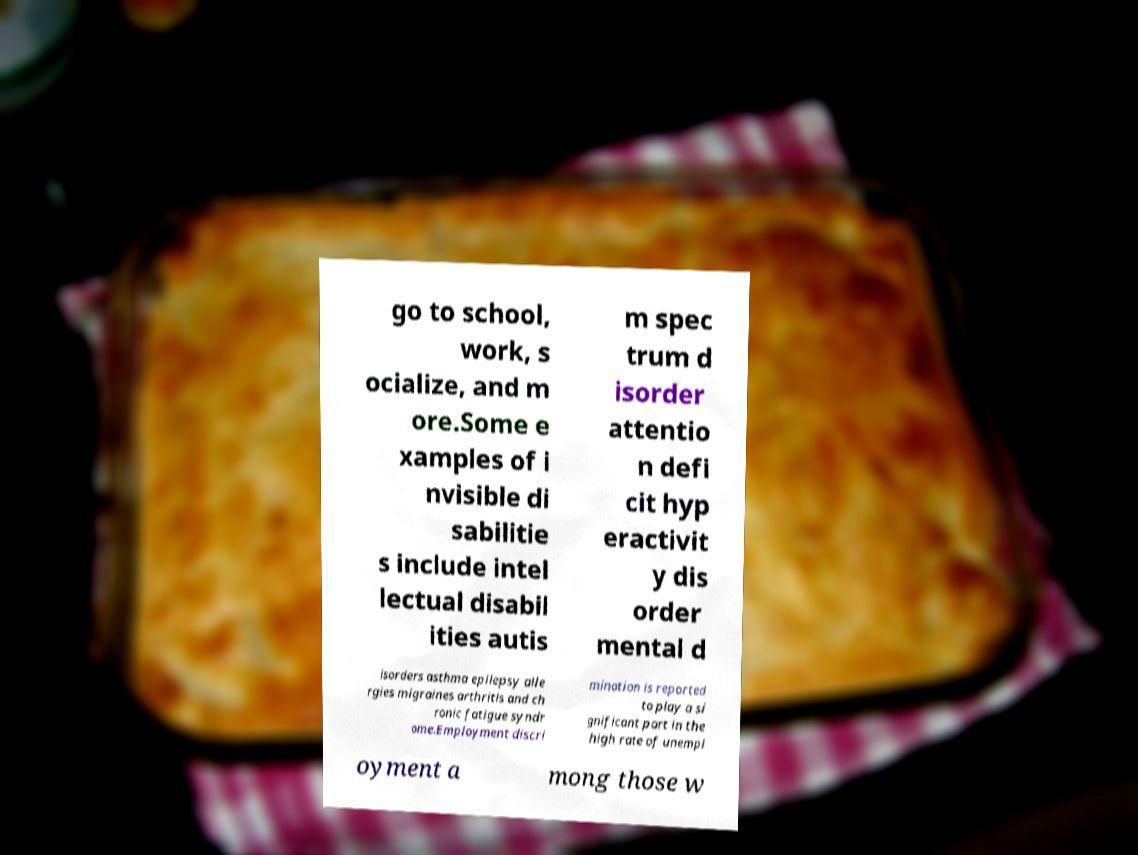What messages or text are displayed in this image? I need them in a readable, typed format. go to school, work, s ocialize, and m ore.Some e xamples of i nvisible di sabilitie s include intel lectual disabil ities autis m spec trum d isorder attentio n defi cit hyp eractivit y dis order mental d isorders asthma epilepsy alle rgies migraines arthritis and ch ronic fatigue syndr ome.Employment discri mination is reported to play a si gnificant part in the high rate of unempl oyment a mong those w 